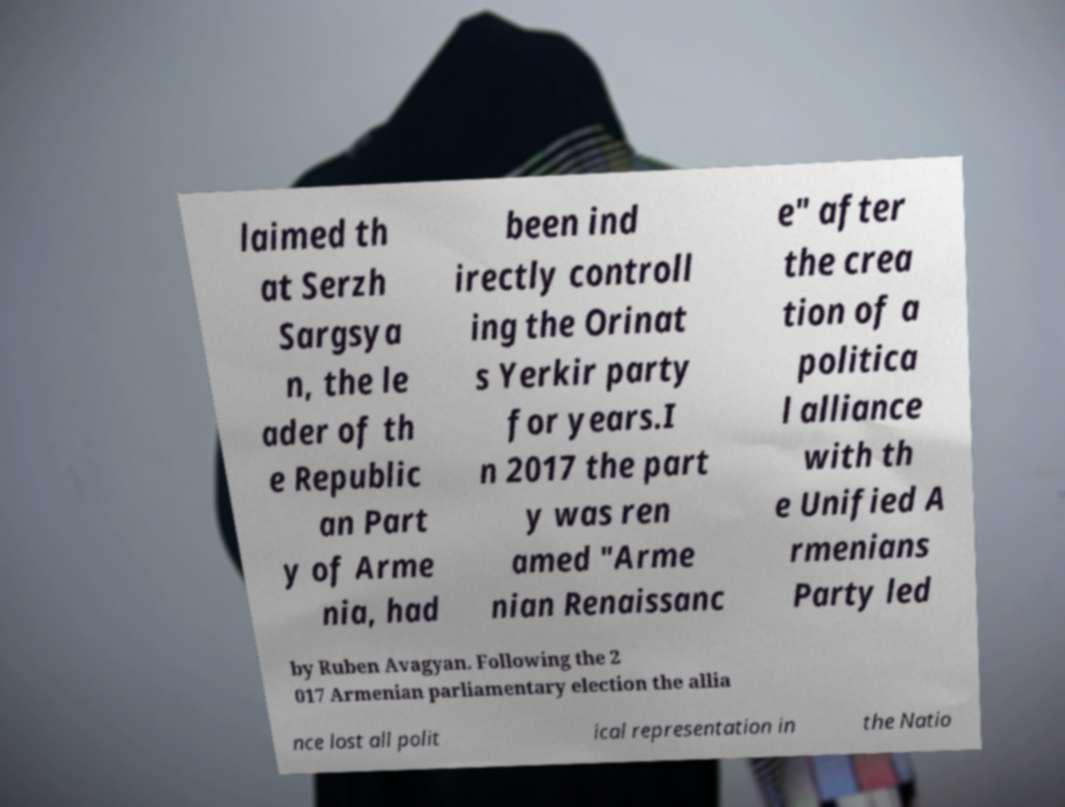There's text embedded in this image that I need extracted. Can you transcribe it verbatim? laimed th at Serzh Sargsya n, the le ader of th e Republic an Part y of Arme nia, had been ind irectly controll ing the Orinat s Yerkir party for years.I n 2017 the part y was ren amed "Arme nian Renaissanc e" after the crea tion of a politica l alliance with th e Unified A rmenians Party led by Ruben Avagyan. Following the 2 017 Armenian parliamentary election the allia nce lost all polit ical representation in the Natio 